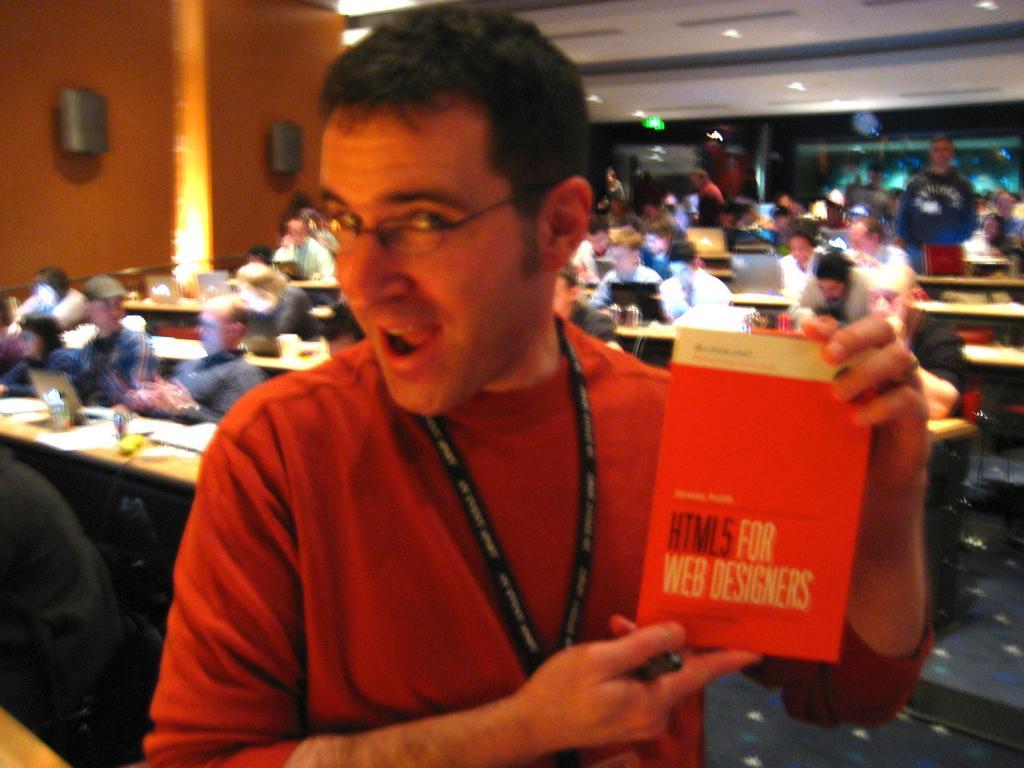Can you describe this image briefly? There is a man wearing specs and tag is holding a book. In the back there are tables. On the table there are laptops and many other items. Many people are sitting in the background. On the wall there is light and some other objects. 